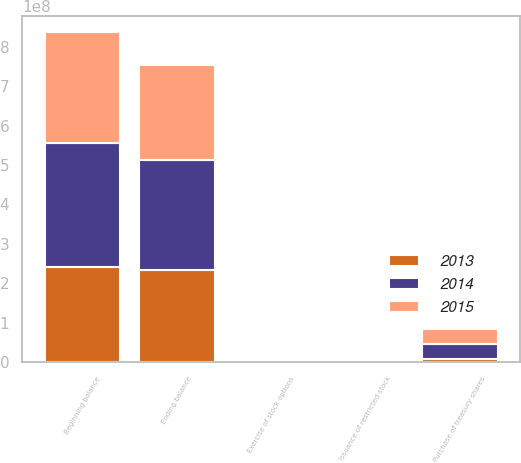Convert chart to OTSL. <chart><loc_0><loc_0><loc_500><loc_500><stacked_bar_chart><ecel><fcel>Beginning balance<fcel>Exercise of stock options<fcel>Issuance of restricted stock<fcel>Purchase of treasury shares<fcel>Ending balance<nl><fcel>2013<fcel>2.41673e+08<fcel>274705<fcel>40673<fcel>8.90687e+06<fcel>2.33082e+08<nl><fcel>2015<fcel>2.79241e+08<fcel>942560<fcel>20875<fcel>3.84657e+07<fcel>2.41673e+08<nl><fcel>2014<fcel>3.14753e+08<fcel>1.13152e+06<fcel>150370<fcel>3.67865e+07<fcel>2.79241e+08<nl></chart> 